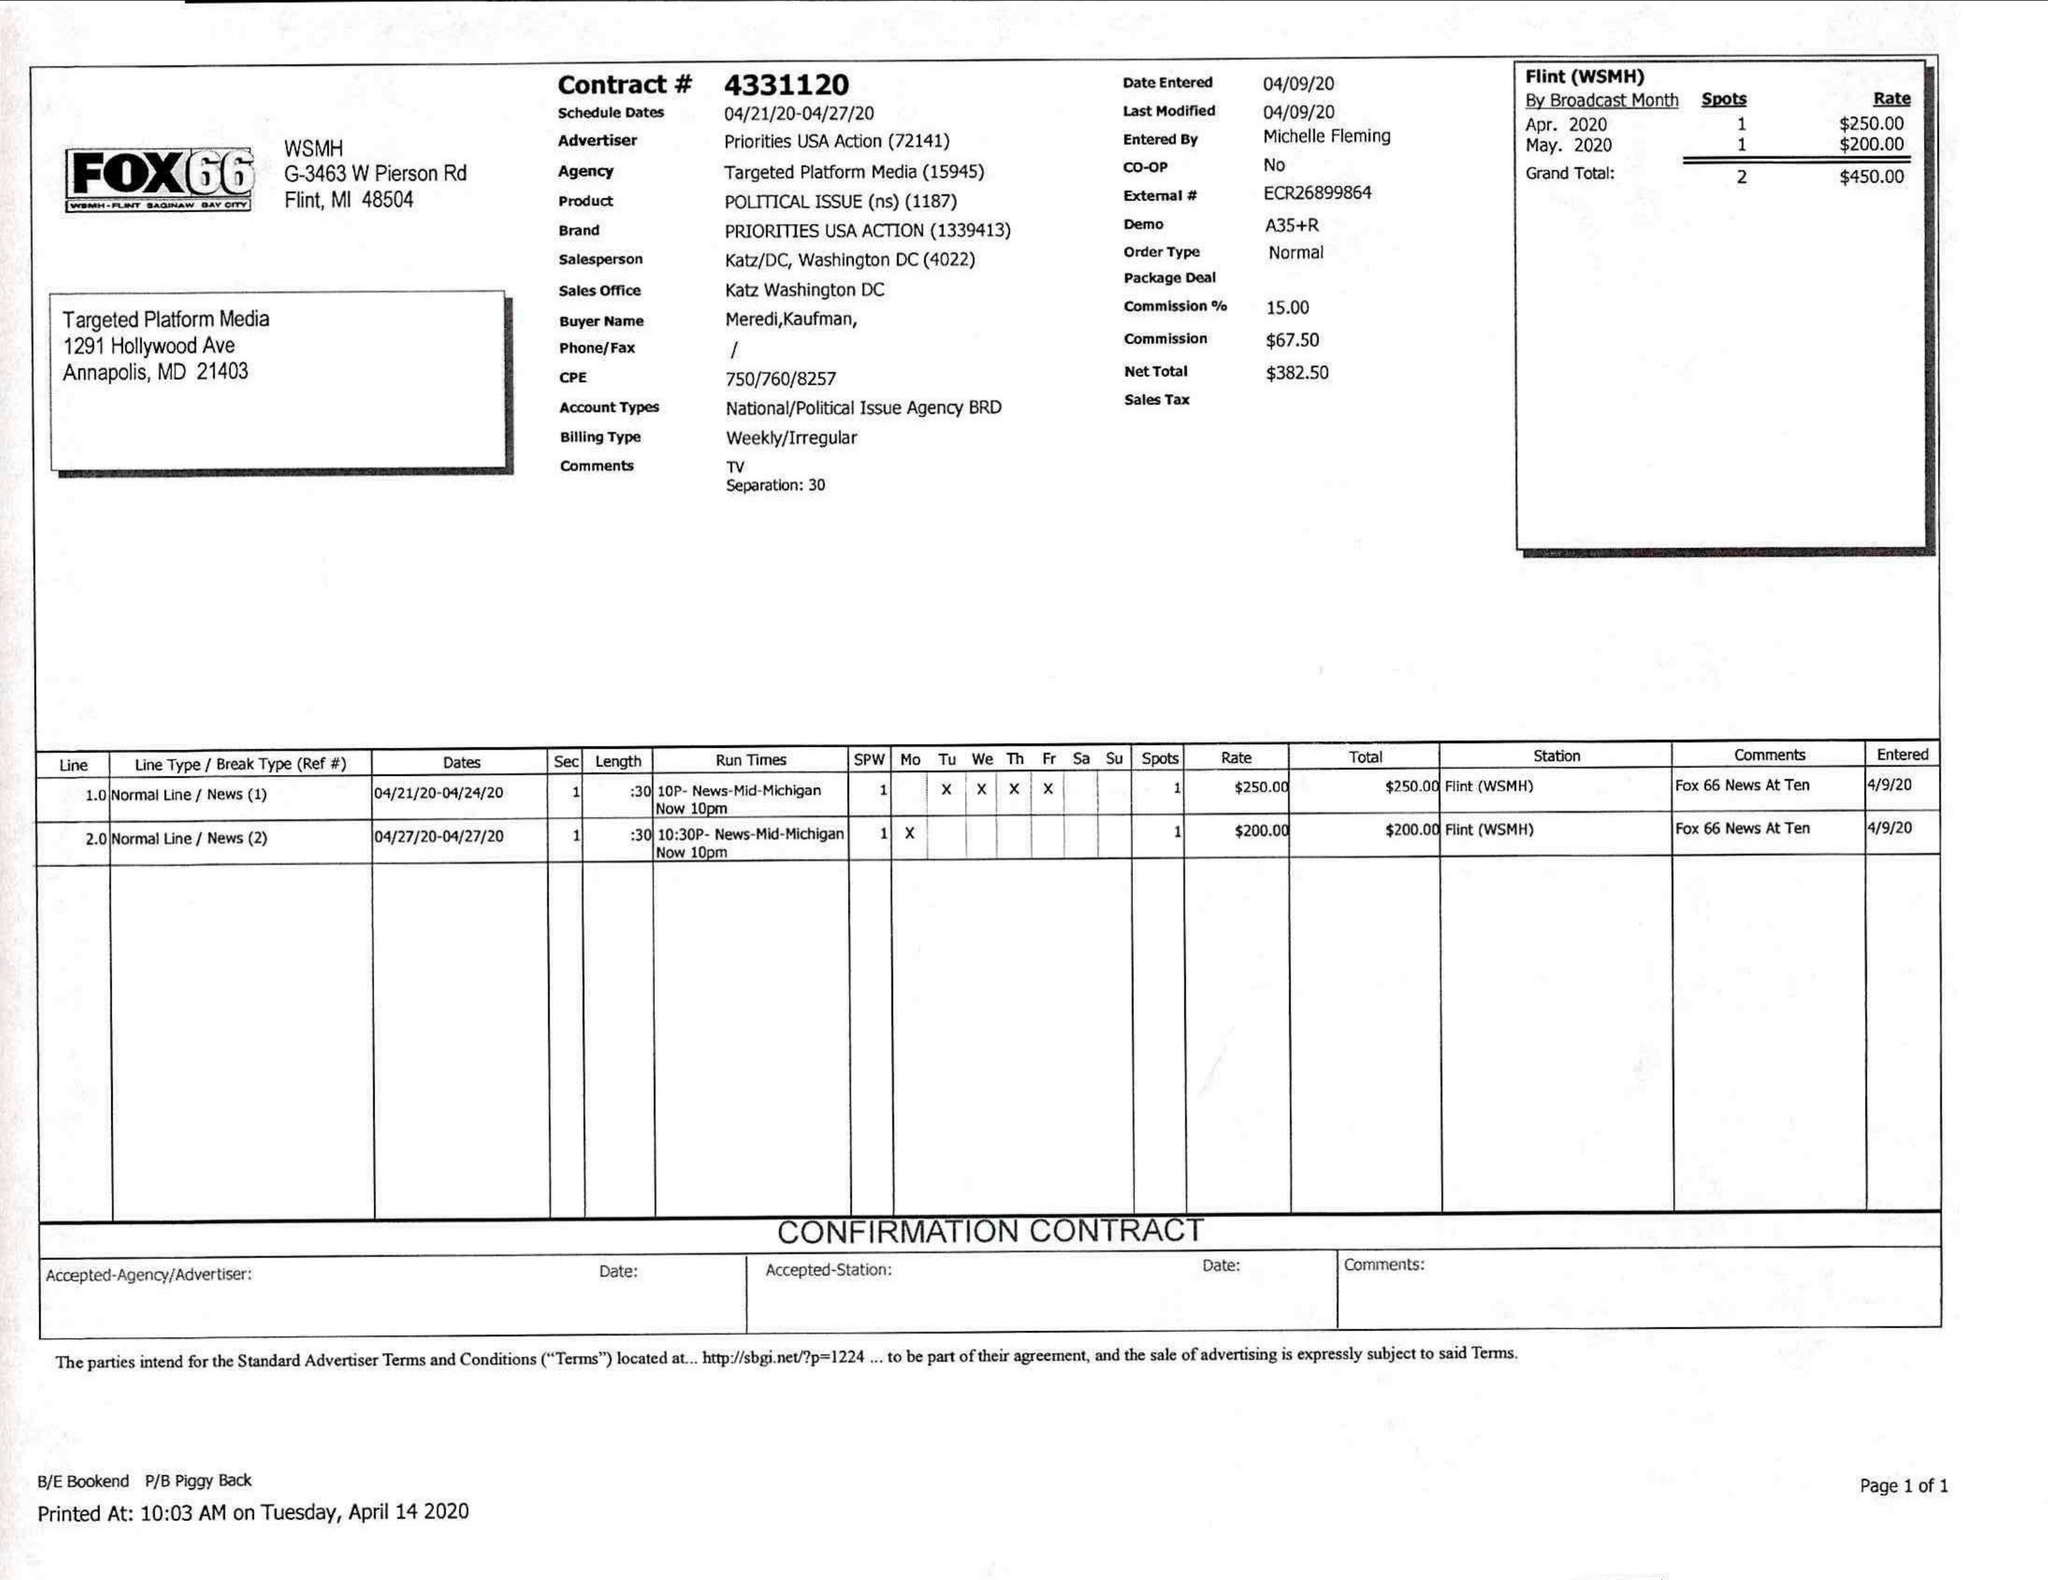What is the value for the advertiser?
Answer the question using a single word or phrase. PRIORITIES USA ACTION 